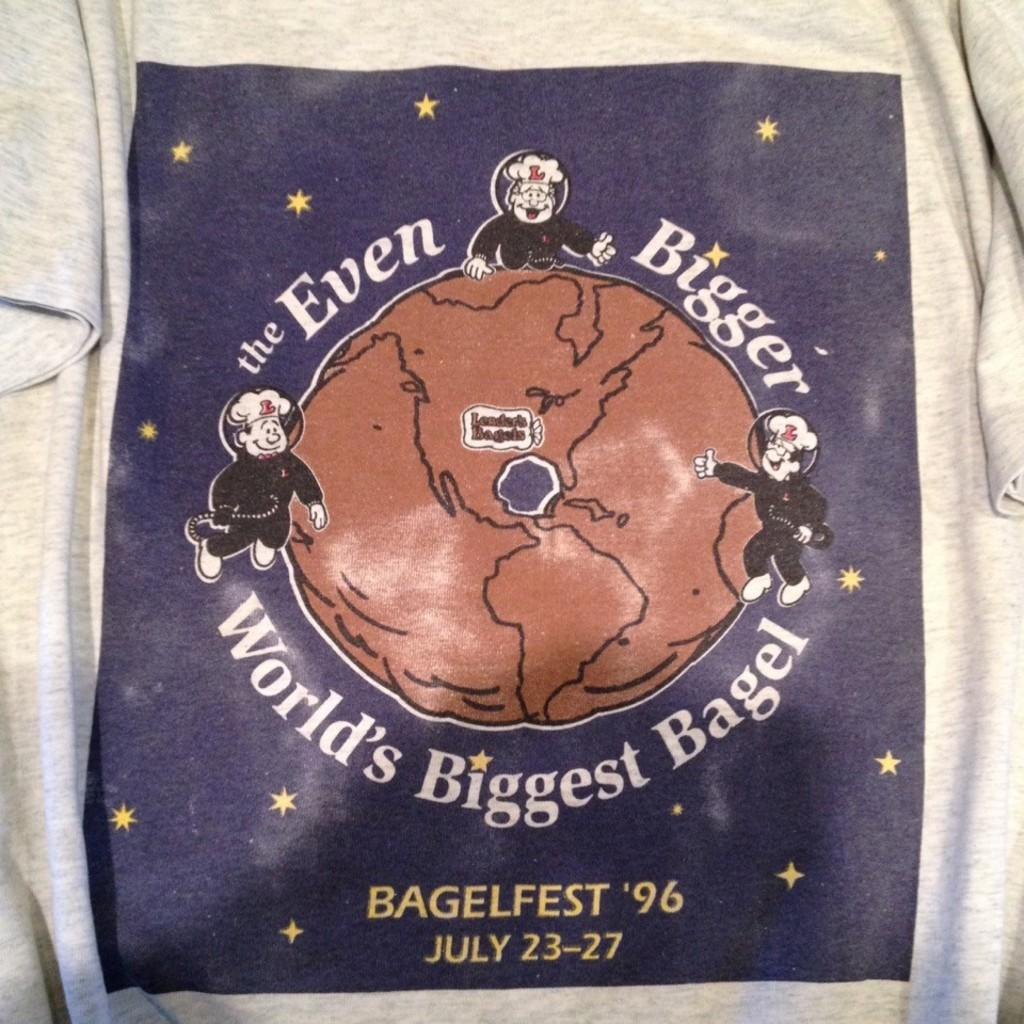What type of clothing item is in the image? There is a T-shirt in the image. What color is the T-shirt? The T-shirt is in ash color. What type of food is being served on the T-shirt in the image? There is no food present on the T-shirt in the image. What type of ground is visible beneath the T-shirt in the image? The image does not show any ground beneath the T-shirt; it only shows the T-shirt itself. 